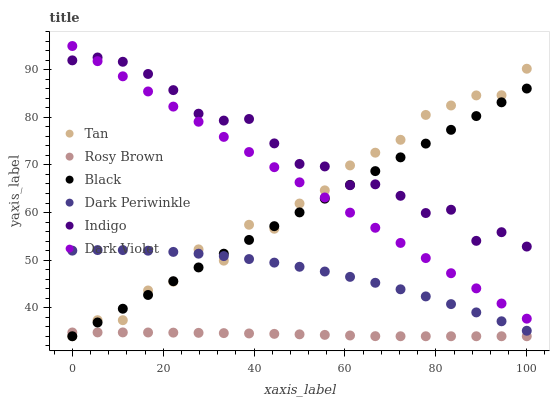Does Rosy Brown have the minimum area under the curve?
Answer yes or no. Yes. Does Indigo have the maximum area under the curve?
Answer yes or no. Yes. Does Dark Violet have the minimum area under the curve?
Answer yes or no. No. Does Dark Violet have the maximum area under the curve?
Answer yes or no. No. Is Dark Violet the smoothest?
Answer yes or no. Yes. Is Tan the roughest?
Answer yes or no. Yes. Is Rosy Brown the smoothest?
Answer yes or no. No. Is Rosy Brown the roughest?
Answer yes or no. No. Does Rosy Brown have the lowest value?
Answer yes or no. Yes. Does Dark Violet have the lowest value?
Answer yes or no. No. Does Dark Violet have the highest value?
Answer yes or no. Yes. Does Rosy Brown have the highest value?
Answer yes or no. No. Is Dark Periwinkle less than Dark Violet?
Answer yes or no. Yes. Is Dark Violet greater than Rosy Brown?
Answer yes or no. Yes. Does Tan intersect Dark Violet?
Answer yes or no. Yes. Is Tan less than Dark Violet?
Answer yes or no. No. Is Tan greater than Dark Violet?
Answer yes or no. No. Does Dark Periwinkle intersect Dark Violet?
Answer yes or no. No. 